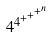Convert formula to latex. <formula><loc_0><loc_0><loc_500><loc_500>4 ^ { 4 ^ { + ^ { + ^ { + ^ { n } } } } }</formula> 